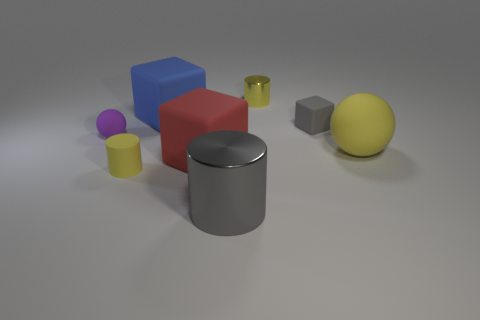Add 2 gray cylinders. How many objects exist? 10 Subtract all balls. How many objects are left? 6 Add 2 yellow shiny things. How many yellow shiny things are left? 3 Add 4 cyan shiny blocks. How many cyan shiny blocks exist? 4 Subtract 0 cyan balls. How many objects are left? 8 Subtract all metallic cylinders. Subtract all small brown spheres. How many objects are left? 6 